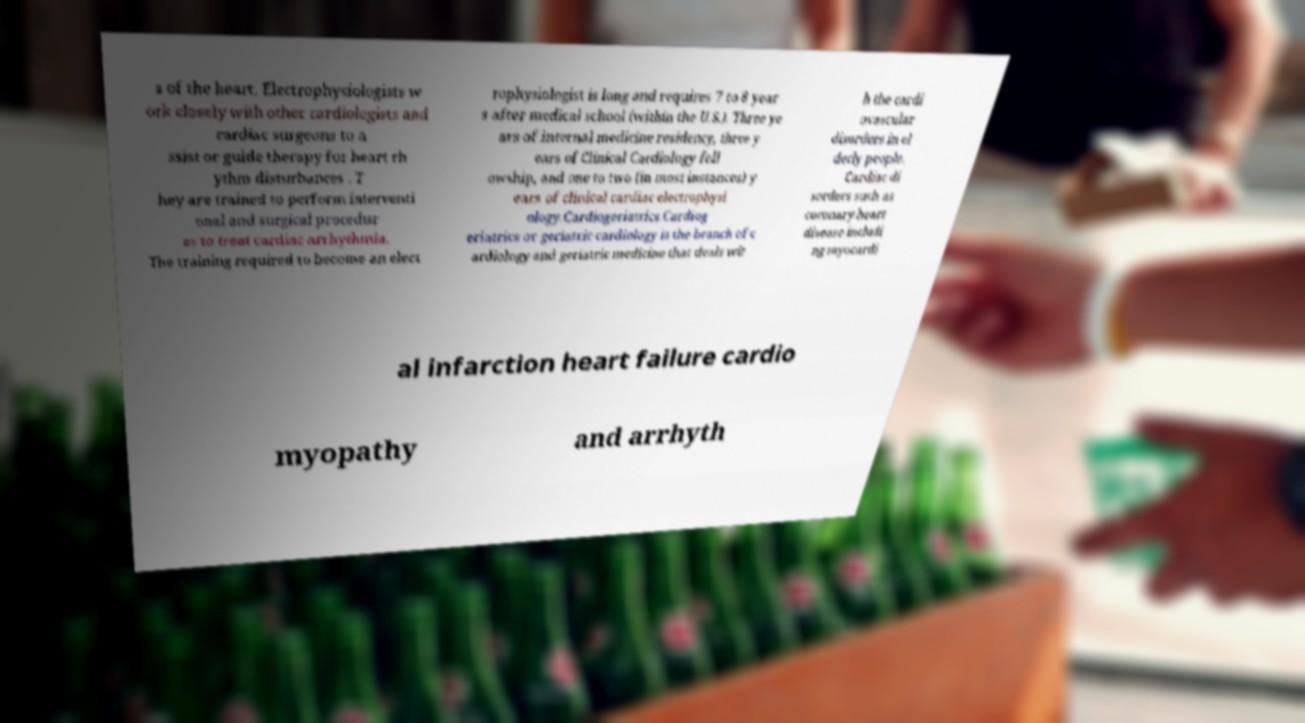Could you extract and type out the text from this image? s of the heart. Electrophysiologists w ork closely with other cardiologists and cardiac surgeons to a ssist or guide therapy for heart rh ythm disturbances . T hey are trained to perform interventi onal and surgical procedur es to treat cardiac arrhythmia. The training required to become an elect rophysiologist is long and requires 7 to 8 year s after medical school (within the U.S.). Three ye ars of internal medicine residency, three y ears of Clinical Cardiology fell owship, and one to two (in most instances) y ears of clinical cardiac electrophysi ology.Cardiogeriatrics.Cardiog eriatrics or geriatric cardiology is the branch of c ardiology and geriatric medicine that deals wit h the cardi ovascular disorders in el derly people. Cardiac di sorders such as coronary heart disease includi ng myocardi al infarction heart failure cardio myopathy and arrhyth 